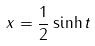<formula> <loc_0><loc_0><loc_500><loc_500>x = \frac { 1 } { 2 } \sinh t</formula> 